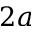<formula> <loc_0><loc_0><loc_500><loc_500>2 a</formula> 